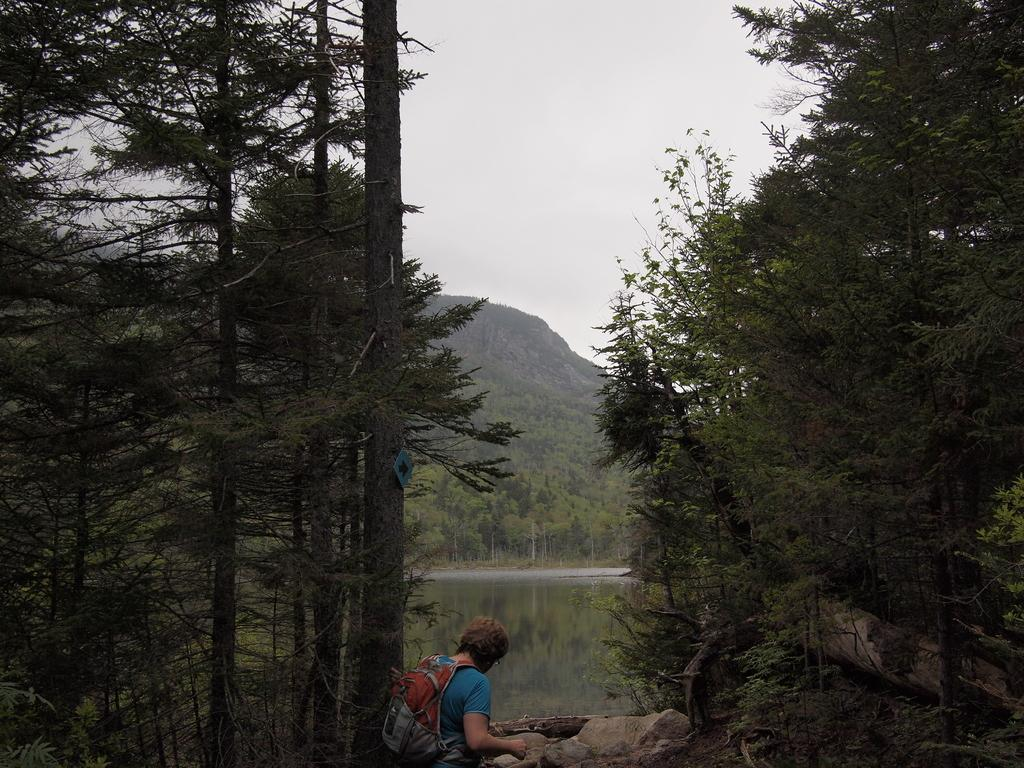What is present in the image? There is a person in the image. What is the person wearing? The person is wearing a bag. What type of natural environment is visible in the image? There are trees, stones, and a lake visible in the image. What type of flag is visible in the image? There is no flag present in the image. How many cakes are visible in the image? There are no cakes present in the image. 